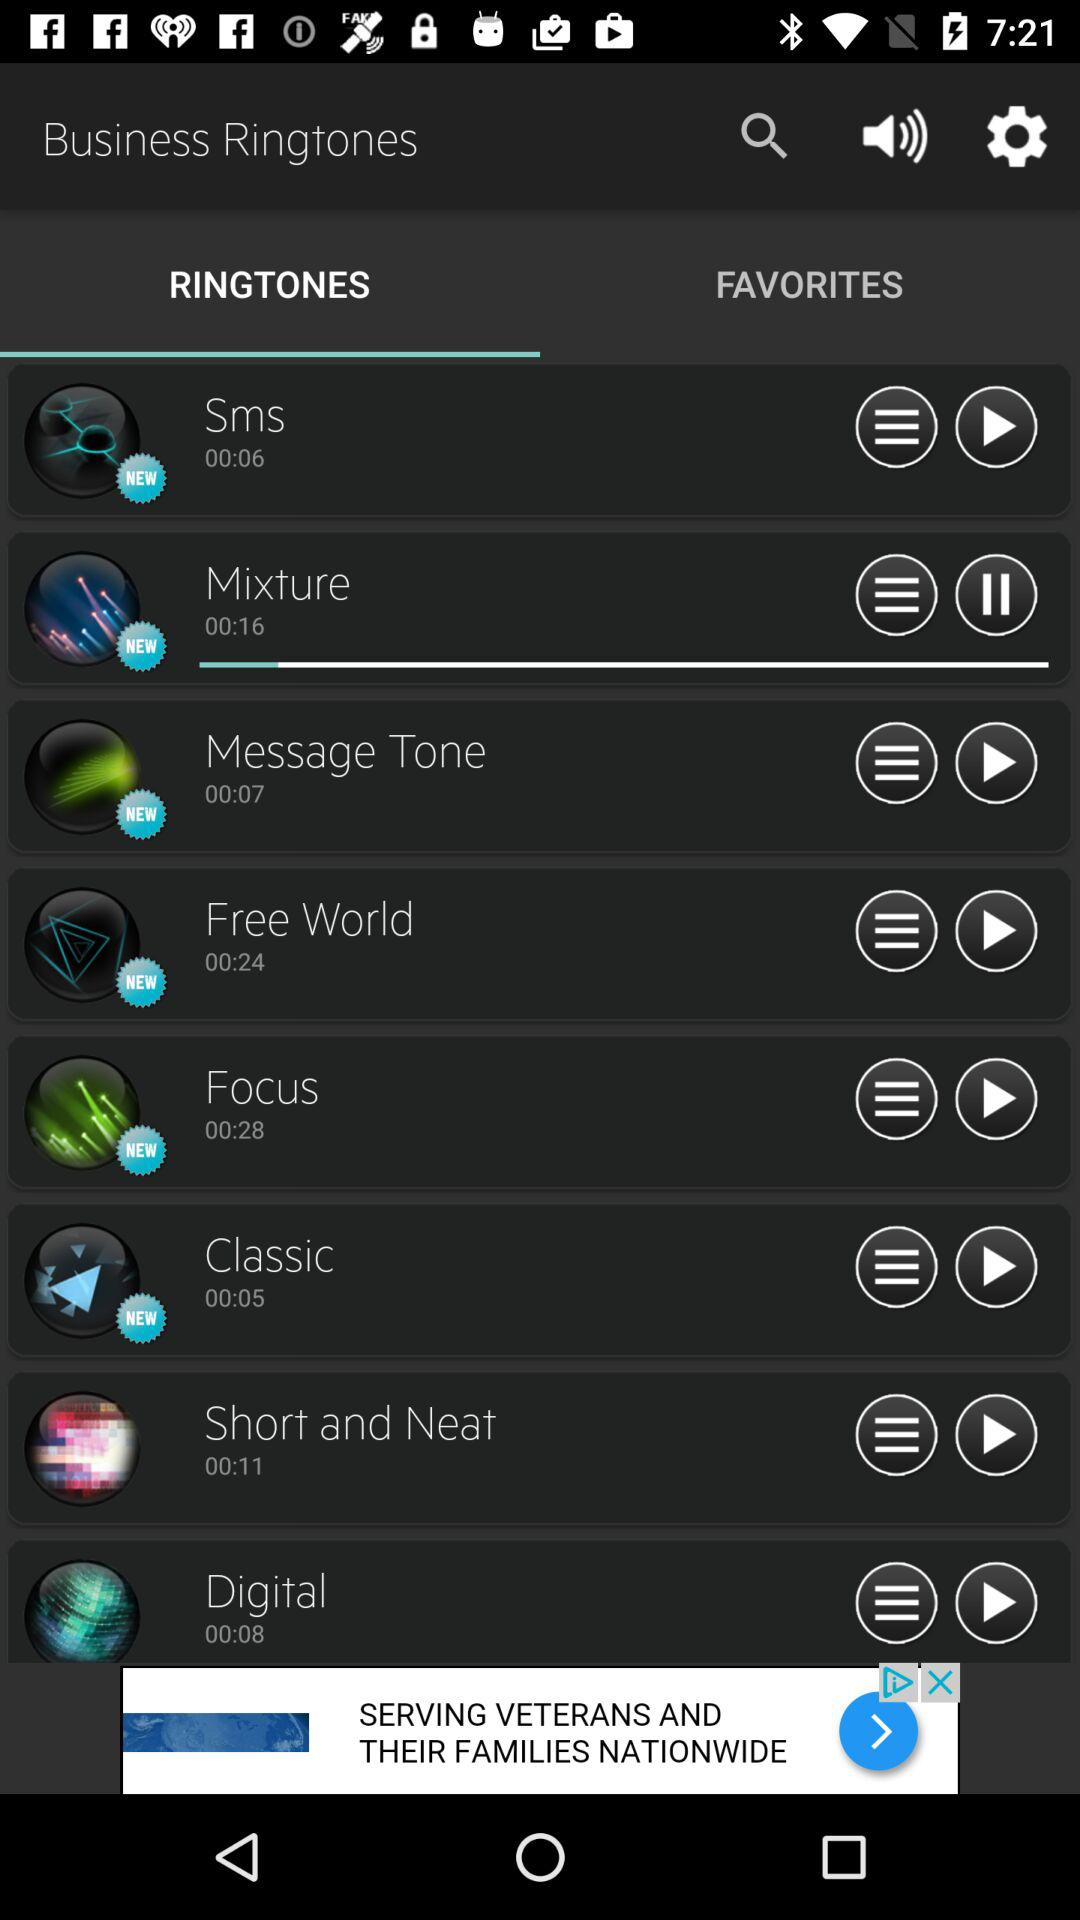Which ringtone is playing? The ringtone is "Mixture". 